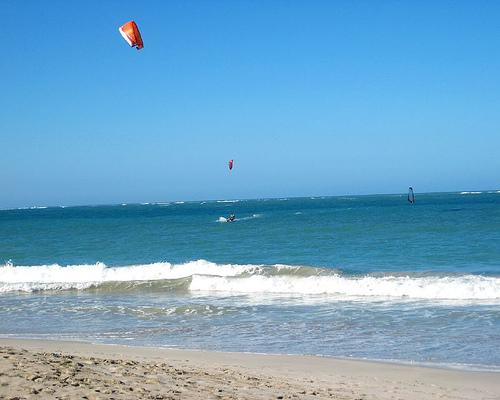Question: what is in the sky?
Choices:
A. Clouds.
B. Kites.
C. The sun.
D. An airplane.
Answer with the letter. Answer: B Question: what is splashing on the shore?
Choices:
A. A swimmer.
B. Waves.
C. A fish.
D. A toddler.
Answer with the letter. Answer: B Question: how many kites are flying?
Choices:
A. 3.
B. 2.
C. 6.
D. 9.
Answer with the letter. Answer: B Question: where was this pic taken?
Choices:
A. In someone's home.
B. At the beach.
C. At the park.
D. At the store.
Answer with the letter. Answer: B Question: what color is the sky?
Choices:
A. Blue.
B. White.
C. Black.
D. Orange.
Answer with the letter. Answer: A Question: what type of day is it?
Choices:
A. Windy and chilly.
B. Nice and clear.
C. Sunny.
D. Cloudy.
Answer with the letter. Answer: B 